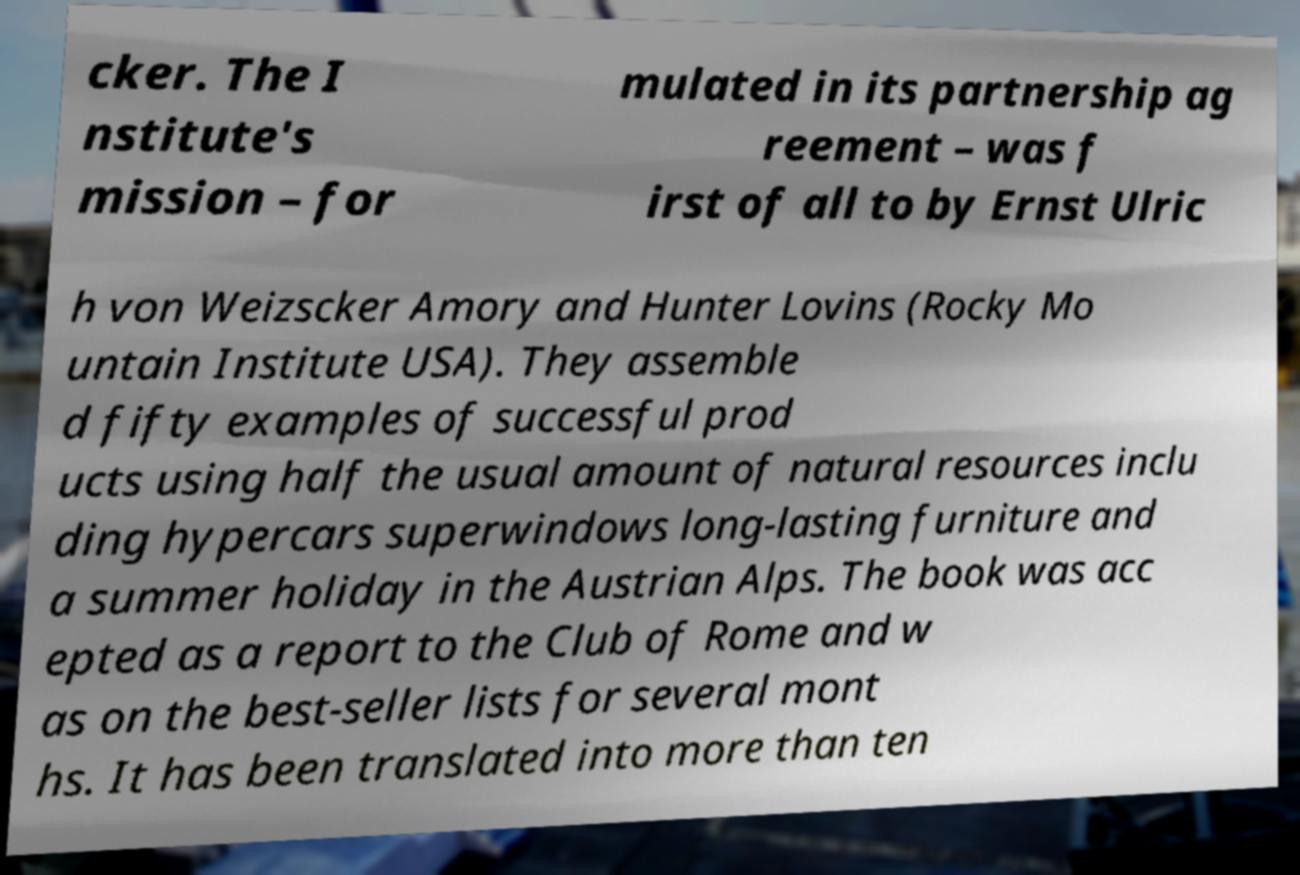Could you extract and type out the text from this image? cker. The I nstitute's mission – for mulated in its partnership ag reement – was f irst of all to by Ernst Ulric h von Weizscker Amory and Hunter Lovins (Rocky Mo untain Institute USA). They assemble d fifty examples of successful prod ucts using half the usual amount of natural resources inclu ding hypercars superwindows long-lasting furniture and a summer holiday in the Austrian Alps. The book was acc epted as a report to the Club of Rome and w as on the best-seller lists for several mont hs. It has been translated into more than ten 